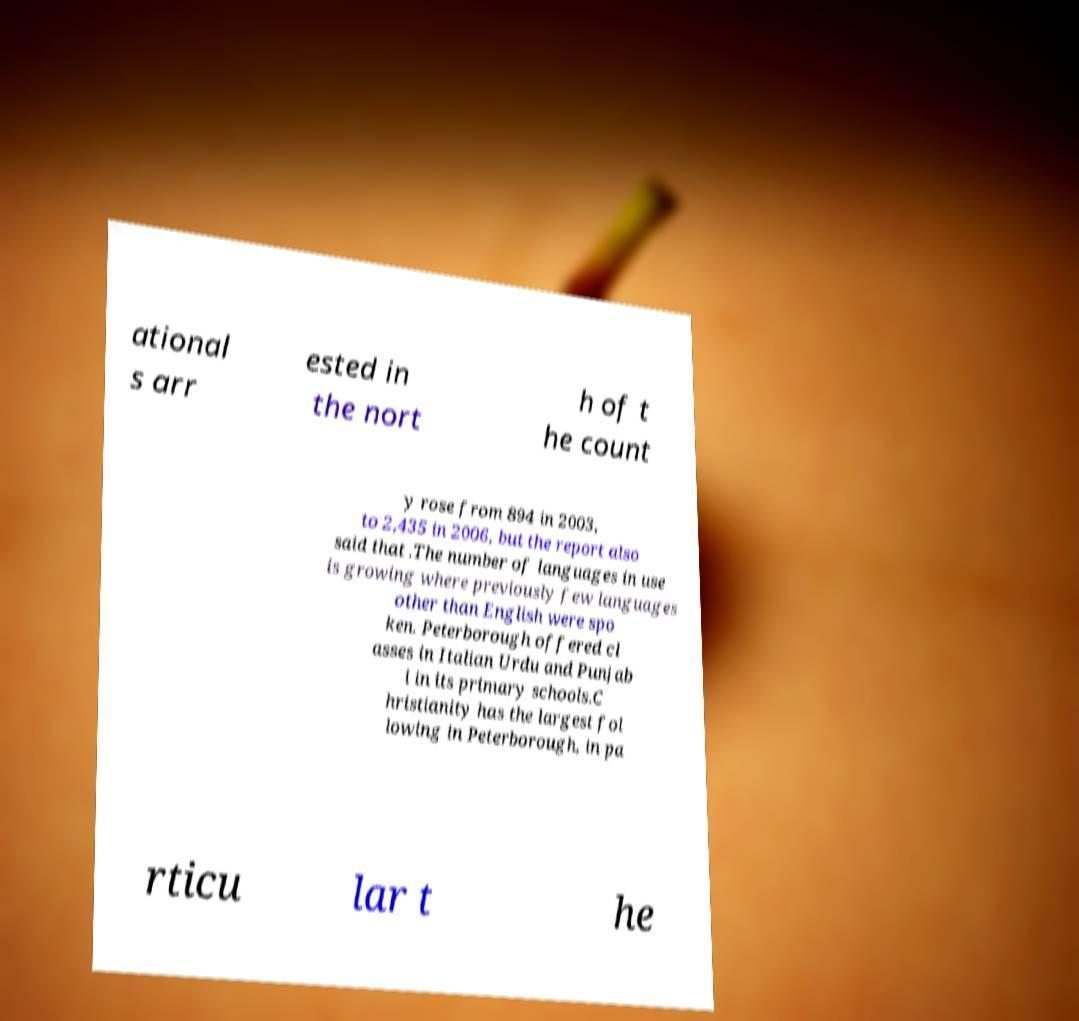Can you accurately transcribe the text from the provided image for me? ational s arr ested in the nort h of t he count y rose from 894 in 2003, to 2,435 in 2006, but the report also said that .The number of languages in use is growing where previously few languages other than English were spo ken. Peterborough offered cl asses in Italian Urdu and Punjab i in its primary schools.C hristianity has the largest fol lowing in Peterborough, in pa rticu lar t he 